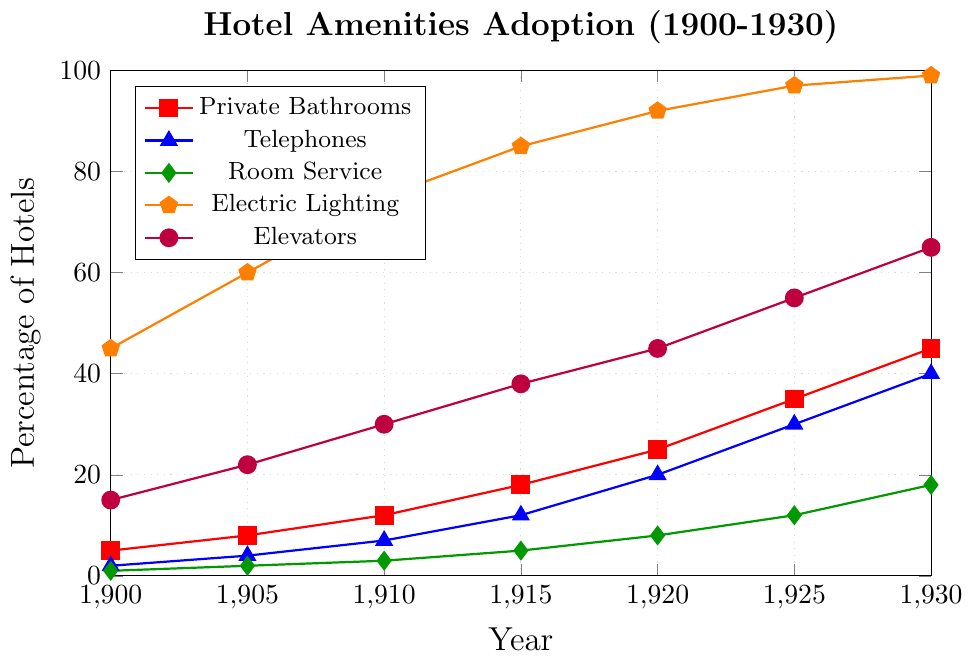What amenity saw the greatest increase in percentage from 1900 to 1930? To find which amenity saw the greatest increase, we need to subtract the 1900 value from the 1930 value for each. Private Bathrooms: 45 - 5 = 40, Telephones: 40 - 2 = 38, Room Service: 18 - 1 = 17, Electric Lighting: 99 - 45 = 54, Elevators: 65 - 15 = 50. The greatest increase is for Electric Lighting with an increase of 54%.
Answer: Electric Lighting Which two amenities had the closest percentage adoption in 1920? Comparing the values from 1920, we have: Private Bathrooms: 25%, Telephones: 20%, Room Service: 8%, Electric Lighting: 92%, Elevators: 45%. The closest percentages are Private Bathrooms and Telephones, both with 5% difference.
Answer: Private Bathrooms and Telephones At what year did the percentage of hotels with Elevators surpass 30%? We need to track when the Elevators data line crosses the 30% mark. In 1910, the percentage is 30% and in 1915, it increases to 38%, so it surpasses in 1915.
Answer: 1915 Which amenity had the smallest increase between 1920 and 1930? We must calculate the increase from 1920 to 1930 for each amenity: Private Bathrooms: 45 - 25 = 20, Telephones: 40 - 20 = 20, Room Service: 18 - 8 = 10, Electric Lighting: 99 - 92 = 7, Elevators: 65 - 45 = 20. Room Service had the smallest increase of 10%.
Answer: Room Service Between which consecutive time periods did Room Service have the highest percent increase? We calculate the percent increase for consecutive periods: (1905:2 - 1900:1)/1 * 100 = 100%, (1910:3 - 1905:2)/2 * 100 = 50%, (1915:5 - 1910:3)/3 * 100 = 66.7%, (1920:8 - 1915:5)/5 * 100 = 60%, (1925:12 - 1920:8)/8 * 100 = 50%, (1930:18 - 1925:12)/12 * 100 = 50%. The highest percent increase was between 1900 and 1905 at 100%.
Answer: 1900 to 1905 When did more than half the hotels offer Electric Lighting? Track when Electric Lighting data line surpasses the 50% mark: In 1900, it's 45%, in 1905 it becomes 60%, so it surpasses 50% in 1905.
Answer: 1905 Compare the adoption rates of Private Bathrooms and Elevators in 1925 In 1925, Private Bathrooms adoption is 35% and Elevators is at 55%, so Elevators were more adopted in that year.
Answer: Elevators What was the percentage increase in Telephones from 1910 to 1920? Calculate the increase: (1920:20 - 1910:7)/7 * 100 = 185.71% increase from 1910 to 1920.
Answer: 185.71% 